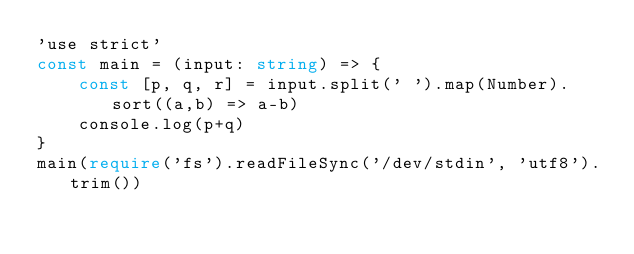Convert code to text. <code><loc_0><loc_0><loc_500><loc_500><_TypeScript_>'use strict'
const main = (input: string) => {
    const [p, q, r] = input.split(' ').map(Number).sort((a,b) => a-b)
    console.log(p+q)
}
main(require('fs').readFileSync('/dev/stdin', 'utf8').trim())</code> 